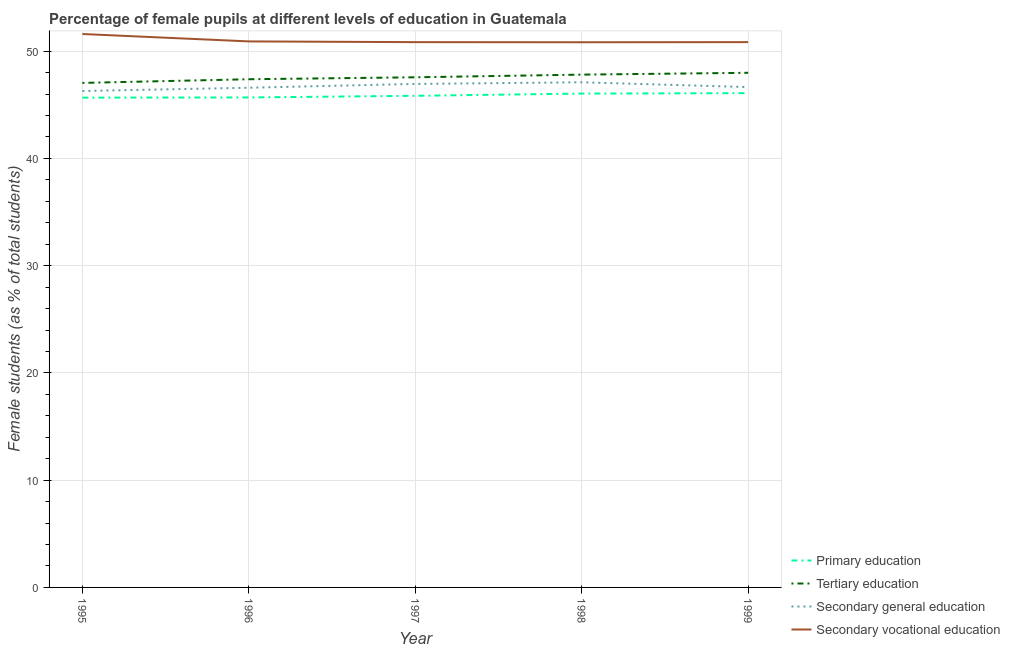How many different coloured lines are there?
Offer a terse response. 4. Is the number of lines equal to the number of legend labels?
Your response must be concise. Yes. What is the percentage of female students in primary education in 1999?
Your answer should be very brief. 46.09. Across all years, what is the maximum percentage of female students in secondary vocational education?
Give a very brief answer. 51.6. Across all years, what is the minimum percentage of female students in primary education?
Provide a succinct answer. 45.67. In which year was the percentage of female students in secondary education minimum?
Provide a succinct answer. 1995. What is the total percentage of female students in primary education in the graph?
Your answer should be very brief. 229.33. What is the difference between the percentage of female students in secondary vocational education in 1995 and that in 1997?
Provide a succinct answer. 0.76. What is the difference between the percentage of female students in secondary vocational education in 1997 and the percentage of female students in tertiary education in 1995?
Offer a very short reply. 3.8. What is the average percentage of female students in secondary vocational education per year?
Give a very brief answer. 51.01. In the year 1996, what is the difference between the percentage of female students in tertiary education and percentage of female students in primary education?
Make the answer very short. 1.7. In how many years, is the percentage of female students in secondary education greater than 22 %?
Your answer should be very brief. 5. What is the ratio of the percentage of female students in tertiary education in 1996 to that in 1997?
Provide a succinct answer. 1. What is the difference between the highest and the second highest percentage of female students in secondary vocational education?
Your answer should be very brief. 0.69. What is the difference between the highest and the lowest percentage of female students in secondary education?
Your answer should be very brief. 0.81. In how many years, is the percentage of female students in primary education greater than the average percentage of female students in primary education taken over all years?
Provide a succinct answer. 2. Is it the case that in every year, the sum of the percentage of female students in primary education and percentage of female students in tertiary education is greater than the percentage of female students in secondary education?
Ensure brevity in your answer.  Yes. Is the percentage of female students in tertiary education strictly less than the percentage of female students in secondary vocational education over the years?
Provide a succinct answer. Yes. How many lines are there?
Provide a short and direct response. 4. What is the difference between two consecutive major ticks on the Y-axis?
Your response must be concise. 10. Are the values on the major ticks of Y-axis written in scientific E-notation?
Give a very brief answer. No. Where does the legend appear in the graph?
Offer a very short reply. Bottom right. What is the title of the graph?
Offer a terse response. Percentage of female pupils at different levels of education in Guatemala. Does "Quality Certification" appear as one of the legend labels in the graph?
Offer a terse response. No. What is the label or title of the Y-axis?
Ensure brevity in your answer.  Female students (as % of total students). What is the Female students (as % of total students) of Primary education in 1995?
Make the answer very short. 45.67. What is the Female students (as % of total students) in Tertiary education in 1995?
Give a very brief answer. 47.04. What is the Female students (as % of total students) of Secondary general education in 1995?
Ensure brevity in your answer.  46.29. What is the Female students (as % of total students) in Secondary vocational education in 1995?
Your answer should be very brief. 51.6. What is the Female students (as % of total students) of Primary education in 1996?
Provide a succinct answer. 45.69. What is the Female students (as % of total students) of Tertiary education in 1996?
Offer a terse response. 47.38. What is the Female students (as % of total students) in Secondary general education in 1996?
Your answer should be very brief. 46.59. What is the Female students (as % of total students) of Secondary vocational education in 1996?
Your response must be concise. 50.91. What is the Female students (as % of total students) in Primary education in 1997?
Make the answer very short. 45.84. What is the Female students (as % of total students) of Tertiary education in 1997?
Make the answer very short. 47.57. What is the Female students (as % of total students) of Secondary general education in 1997?
Keep it short and to the point. 46.95. What is the Female students (as % of total students) of Secondary vocational education in 1997?
Your response must be concise. 50.84. What is the Female students (as % of total students) of Primary education in 1998?
Provide a short and direct response. 46.05. What is the Female students (as % of total students) of Tertiary education in 1998?
Ensure brevity in your answer.  47.81. What is the Female students (as % of total students) of Secondary general education in 1998?
Provide a succinct answer. 47.1. What is the Female students (as % of total students) of Secondary vocational education in 1998?
Offer a very short reply. 50.83. What is the Female students (as % of total students) of Primary education in 1999?
Keep it short and to the point. 46.09. What is the Female students (as % of total students) of Tertiary education in 1999?
Offer a terse response. 47.98. What is the Female students (as % of total students) of Secondary general education in 1999?
Offer a terse response. 46.65. What is the Female students (as % of total students) of Secondary vocational education in 1999?
Your answer should be compact. 50.84. Across all years, what is the maximum Female students (as % of total students) of Primary education?
Give a very brief answer. 46.09. Across all years, what is the maximum Female students (as % of total students) of Tertiary education?
Make the answer very short. 47.98. Across all years, what is the maximum Female students (as % of total students) in Secondary general education?
Offer a very short reply. 47.1. Across all years, what is the maximum Female students (as % of total students) of Secondary vocational education?
Offer a very short reply. 51.6. Across all years, what is the minimum Female students (as % of total students) of Primary education?
Provide a succinct answer. 45.67. Across all years, what is the minimum Female students (as % of total students) of Tertiary education?
Offer a very short reply. 47.04. Across all years, what is the minimum Female students (as % of total students) of Secondary general education?
Give a very brief answer. 46.29. Across all years, what is the minimum Female students (as % of total students) in Secondary vocational education?
Provide a short and direct response. 50.83. What is the total Female students (as % of total students) in Primary education in the graph?
Your answer should be compact. 229.33. What is the total Female students (as % of total students) in Tertiary education in the graph?
Ensure brevity in your answer.  237.79. What is the total Female students (as % of total students) of Secondary general education in the graph?
Give a very brief answer. 233.58. What is the total Female students (as % of total students) in Secondary vocational education in the graph?
Offer a very short reply. 255.03. What is the difference between the Female students (as % of total students) in Primary education in 1995 and that in 1996?
Your answer should be very brief. -0.02. What is the difference between the Female students (as % of total students) in Tertiary education in 1995 and that in 1996?
Give a very brief answer. -0.34. What is the difference between the Female students (as % of total students) of Secondary general education in 1995 and that in 1996?
Keep it short and to the point. -0.3. What is the difference between the Female students (as % of total students) in Secondary vocational education in 1995 and that in 1996?
Ensure brevity in your answer.  0.69. What is the difference between the Female students (as % of total students) in Primary education in 1995 and that in 1997?
Provide a short and direct response. -0.17. What is the difference between the Female students (as % of total students) of Tertiary education in 1995 and that in 1997?
Make the answer very short. -0.52. What is the difference between the Female students (as % of total students) in Secondary general education in 1995 and that in 1997?
Provide a short and direct response. -0.66. What is the difference between the Female students (as % of total students) of Secondary vocational education in 1995 and that in 1997?
Offer a terse response. 0.76. What is the difference between the Female students (as % of total students) of Primary education in 1995 and that in 1998?
Provide a succinct answer. -0.38. What is the difference between the Female students (as % of total students) in Tertiary education in 1995 and that in 1998?
Give a very brief answer. -0.77. What is the difference between the Female students (as % of total students) in Secondary general education in 1995 and that in 1998?
Keep it short and to the point. -0.81. What is the difference between the Female students (as % of total students) of Secondary vocational education in 1995 and that in 1998?
Make the answer very short. 0.77. What is the difference between the Female students (as % of total students) in Primary education in 1995 and that in 1999?
Offer a terse response. -0.42. What is the difference between the Female students (as % of total students) in Tertiary education in 1995 and that in 1999?
Ensure brevity in your answer.  -0.94. What is the difference between the Female students (as % of total students) in Secondary general education in 1995 and that in 1999?
Offer a terse response. -0.37. What is the difference between the Female students (as % of total students) in Secondary vocational education in 1995 and that in 1999?
Keep it short and to the point. 0.76. What is the difference between the Female students (as % of total students) in Primary education in 1996 and that in 1997?
Your response must be concise. -0.15. What is the difference between the Female students (as % of total students) in Tertiary education in 1996 and that in 1997?
Your response must be concise. -0.18. What is the difference between the Female students (as % of total students) of Secondary general education in 1996 and that in 1997?
Keep it short and to the point. -0.35. What is the difference between the Female students (as % of total students) of Secondary vocational education in 1996 and that in 1997?
Make the answer very short. 0.07. What is the difference between the Female students (as % of total students) in Primary education in 1996 and that in 1998?
Provide a short and direct response. -0.36. What is the difference between the Female students (as % of total students) in Tertiary education in 1996 and that in 1998?
Ensure brevity in your answer.  -0.43. What is the difference between the Female students (as % of total students) in Secondary general education in 1996 and that in 1998?
Your answer should be compact. -0.51. What is the difference between the Female students (as % of total students) of Secondary vocational education in 1996 and that in 1998?
Offer a terse response. 0.08. What is the difference between the Female students (as % of total students) in Primary education in 1996 and that in 1999?
Provide a short and direct response. -0.4. What is the difference between the Female students (as % of total students) in Tertiary education in 1996 and that in 1999?
Offer a very short reply. -0.6. What is the difference between the Female students (as % of total students) in Secondary general education in 1996 and that in 1999?
Provide a short and direct response. -0.06. What is the difference between the Female students (as % of total students) in Secondary vocational education in 1996 and that in 1999?
Provide a short and direct response. 0.07. What is the difference between the Female students (as % of total students) in Primary education in 1997 and that in 1998?
Provide a succinct answer. -0.21. What is the difference between the Female students (as % of total students) in Tertiary education in 1997 and that in 1998?
Give a very brief answer. -0.25. What is the difference between the Female students (as % of total students) of Secondary general education in 1997 and that in 1998?
Make the answer very short. -0.15. What is the difference between the Female students (as % of total students) of Secondary vocational education in 1997 and that in 1998?
Keep it short and to the point. 0.01. What is the difference between the Female students (as % of total students) of Primary education in 1997 and that in 1999?
Offer a very short reply. -0.25. What is the difference between the Female students (as % of total students) in Tertiary education in 1997 and that in 1999?
Provide a succinct answer. -0.42. What is the difference between the Female students (as % of total students) of Secondary general education in 1997 and that in 1999?
Offer a very short reply. 0.29. What is the difference between the Female students (as % of total students) of Secondary vocational education in 1997 and that in 1999?
Provide a succinct answer. -0. What is the difference between the Female students (as % of total students) in Primary education in 1998 and that in 1999?
Offer a terse response. -0.04. What is the difference between the Female students (as % of total students) in Tertiary education in 1998 and that in 1999?
Keep it short and to the point. -0.17. What is the difference between the Female students (as % of total students) of Secondary general education in 1998 and that in 1999?
Give a very brief answer. 0.45. What is the difference between the Female students (as % of total students) of Secondary vocational education in 1998 and that in 1999?
Keep it short and to the point. -0.01. What is the difference between the Female students (as % of total students) in Primary education in 1995 and the Female students (as % of total students) in Tertiary education in 1996?
Your response must be concise. -1.72. What is the difference between the Female students (as % of total students) of Primary education in 1995 and the Female students (as % of total students) of Secondary general education in 1996?
Your answer should be very brief. -0.93. What is the difference between the Female students (as % of total students) of Primary education in 1995 and the Female students (as % of total students) of Secondary vocational education in 1996?
Ensure brevity in your answer.  -5.24. What is the difference between the Female students (as % of total students) of Tertiary education in 1995 and the Female students (as % of total students) of Secondary general education in 1996?
Your answer should be very brief. 0.45. What is the difference between the Female students (as % of total students) of Tertiary education in 1995 and the Female students (as % of total students) of Secondary vocational education in 1996?
Offer a very short reply. -3.87. What is the difference between the Female students (as % of total students) of Secondary general education in 1995 and the Female students (as % of total students) of Secondary vocational education in 1996?
Provide a succinct answer. -4.62. What is the difference between the Female students (as % of total students) of Primary education in 1995 and the Female students (as % of total students) of Tertiary education in 1997?
Your answer should be very brief. -1.9. What is the difference between the Female students (as % of total students) in Primary education in 1995 and the Female students (as % of total students) in Secondary general education in 1997?
Provide a short and direct response. -1.28. What is the difference between the Female students (as % of total students) in Primary education in 1995 and the Female students (as % of total students) in Secondary vocational education in 1997?
Give a very brief answer. -5.18. What is the difference between the Female students (as % of total students) of Tertiary education in 1995 and the Female students (as % of total students) of Secondary general education in 1997?
Your answer should be compact. 0.09. What is the difference between the Female students (as % of total students) of Tertiary education in 1995 and the Female students (as % of total students) of Secondary vocational education in 1997?
Keep it short and to the point. -3.8. What is the difference between the Female students (as % of total students) of Secondary general education in 1995 and the Female students (as % of total students) of Secondary vocational education in 1997?
Make the answer very short. -4.56. What is the difference between the Female students (as % of total students) in Primary education in 1995 and the Female students (as % of total students) in Tertiary education in 1998?
Offer a very short reply. -2.15. What is the difference between the Female students (as % of total students) in Primary education in 1995 and the Female students (as % of total students) in Secondary general education in 1998?
Offer a terse response. -1.43. What is the difference between the Female students (as % of total students) in Primary education in 1995 and the Female students (as % of total students) in Secondary vocational education in 1998?
Provide a short and direct response. -5.17. What is the difference between the Female students (as % of total students) in Tertiary education in 1995 and the Female students (as % of total students) in Secondary general education in 1998?
Offer a very short reply. -0.06. What is the difference between the Female students (as % of total students) in Tertiary education in 1995 and the Female students (as % of total students) in Secondary vocational education in 1998?
Offer a very short reply. -3.79. What is the difference between the Female students (as % of total students) in Secondary general education in 1995 and the Female students (as % of total students) in Secondary vocational education in 1998?
Give a very brief answer. -4.55. What is the difference between the Female students (as % of total students) of Primary education in 1995 and the Female students (as % of total students) of Tertiary education in 1999?
Provide a short and direct response. -2.32. What is the difference between the Female students (as % of total students) in Primary education in 1995 and the Female students (as % of total students) in Secondary general education in 1999?
Your answer should be very brief. -0.99. What is the difference between the Female students (as % of total students) of Primary education in 1995 and the Female students (as % of total students) of Secondary vocational education in 1999?
Your response must be concise. -5.18. What is the difference between the Female students (as % of total students) in Tertiary education in 1995 and the Female students (as % of total students) in Secondary general education in 1999?
Provide a short and direct response. 0.39. What is the difference between the Female students (as % of total students) in Tertiary education in 1995 and the Female students (as % of total students) in Secondary vocational education in 1999?
Make the answer very short. -3.8. What is the difference between the Female students (as % of total students) in Secondary general education in 1995 and the Female students (as % of total students) in Secondary vocational education in 1999?
Give a very brief answer. -4.56. What is the difference between the Female students (as % of total students) in Primary education in 1996 and the Female students (as % of total students) in Tertiary education in 1997?
Offer a terse response. -1.88. What is the difference between the Female students (as % of total students) of Primary education in 1996 and the Female students (as % of total students) of Secondary general education in 1997?
Give a very brief answer. -1.26. What is the difference between the Female students (as % of total students) in Primary education in 1996 and the Female students (as % of total students) in Secondary vocational education in 1997?
Keep it short and to the point. -5.16. What is the difference between the Female students (as % of total students) in Tertiary education in 1996 and the Female students (as % of total students) in Secondary general education in 1997?
Your response must be concise. 0.44. What is the difference between the Female students (as % of total students) of Tertiary education in 1996 and the Female students (as % of total students) of Secondary vocational education in 1997?
Make the answer very short. -3.46. What is the difference between the Female students (as % of total students) of Secondary general education in 1996 and the Female students (as % of total students) of Secondary vocational education in 1997?
Offer a terse response. -4.25. What is the difference between the Female students (as % of total students) in Primary education in 1996 and the Female students (as % of total students) in Tertiary education in 1998?
Keep it short and to the point. -2.13. What is the difference between the Female students (as % of total students) of Primary education in 1996 and the Female students (as % of total students) of Secondary general education in 1998?
Your answer should be very brief. -1.41. What is the difference between the Female students (as % of total students) of Primary education in 1996 and the Female students (as % of total students) of Secondary vocational education in 1998?
Your answer should be very brief. -5.15. What is the difference between the Female students (as % of total students) in Tertiary education in 1996 and the Female students (as % of total students) in Secondary general education in 1998?
Your response must be concise. 0.29. What is the difference between the Female students (as % of total students) in Tertiary education in 1996 and the Female students (as % of total students) in Secondary vocational education in 1998?
Give a very brief answer. -3.45. What is the difference between the Female students (as % of total students) in Secondary general education in 1996 and the Female students (as % of total students) in Secondary vocational education in 1998?
Provide a succinct answer. -4.24. What is the difference between the Female students (as % of total students) of Primary education in 1996 and the Female students (as % of total students) of Tertiary education in 1999?
Provide a short and direct response. -2.3. What is the difference between the Female students (as % of total students) in Primary education in 1996 and the Female students (as % of total students) in Secondary general education in 1999?
Provide a succinct answer. -0.97. What is the difference between the Female students (as % of total students) in Primary education in 1996 and the Female students (as % of total students) in Secondary vocational education in 1999?
Your answer should be compact. -5.16. What is the difference between the Female students (as % of total students) of Tertiary education in 1996 and the Female students (as % of total students) of Secondary general education in 1999?
Offer a terse response. 0.73. What is the difference between the Female students (as % of total students) in Tertiary education in 1996 and the Female students (as % of total students) in Secondary vocational education in 1999?
Ensure brevity in your answer.  -3.46. What is the difference between the Female students (as % of total students) in Secondary general education in 1996 and the Female students (as % of total students) in Secondary vocational education in 1999?
Your answer should be compact. -4.25. What is the difference between the Female students (as % of total students) in Primary education in 1997 and the Female students (as % of total students) in Tertiary education in 1998?
Provide a succinct answer. -1.97. What is the difference between the Female students (as % of total students) of Primary education in 1997 and the Female students (as % of total students) of Secondary general education in 1998?
Keep it short and to the point. -1.26. What is the difference between the Female students (as % of total students) of Primary education in 1997 and the Female students (as % of total students) of Secondary vocational education in 1998?
Give a very brief answer. -4.99. What is the difference between the Female students (as % of total students) of Tertiary education in 1997 and the Female students (as % of total students) of Secondary general education in 1998?
Your answer should be compact. 0.47. What is the difference between the Female students (as % of total students) in Tertiary education in 1997 and the Female students (as % of total students) in Secondary vocational education in 1998?
Ensure brevity in your answer.  -3.27. What is the difference between the Female students (as % of total students) of Secondary general education in 1997 and the Female students (as % of total students) of Secondary vocational education in 1998?
Your response must be concise. -3.89. What is the difference between the Female students (as % of total students) of Primary education in 1997 and the Female students (as % of total students) of Tertiary education in 1999?
Offer a terse response. -2.14. What is the difference between the Female students (as % of total students) of Primary education in 1997 and the Female students (as % of total students) of Secondary general education in 1999?
Your response must be concise. -0.81. What is the difference between the Female students (as % of total students) in Primary education in 1997 and the Female students (as % of total students) in Secondary vocational education in 1999?
Offer a very short reply. -5. What is the difference between the Female students (as % of total students) in Tertiary education in 1997 and the Female students (as % of total students) in Secondary general education in 1999?
Your response must be concise. 0.91. What is the difference between the Female students (as % of total students) of Tertiary education in 1997 and the Female students (as % of total students) of Secondary vocational education in 1999?
Provide a succinct answer. -3.28. What is the difference between the Female students (as % of total students) of Secondary general education in 1997 and the Female students (as % of total students) of Secondary vocational education in 1999?
Ensure brevity in your answer.  -3.9. What is the difference between the Female students (as % of total students) in Primary education in 1998 and the Female students (as % of total students) in Tertiary education in 1999?
Keep it short and to the point. -1.94. What is the difference between the Female students (as % of total students) in Primary education in 1998 and the Female students (as % of total students) in Secondary general education in 1999?
Your answer should be compact. -0.61. What is the difference between the Female students (as % of total students) of Primary education in 1998 and the Female students (as % of total students) of Secondary vocational education in 1999?
Your answer should be very brief. -4.8. What is the difference between the Female students (as % of total students) in Tertiary education in 1998 and the Female students (as % of total students) in Secondary general education in 1999?
Provide a succinct answer. 1.16. What is the difference between the Female students (as % of total students) in Tertiary education in 1998 and the Female students (as % of total students) in Secondary vocational education in 1999?
Offer a terse response. -3.03. What is the difference between the Female students (as % of total students) of Secondary general education in 1998 and the Female students (as % of total students) of Secondary vocational education in 1999?
Provide a succinct answer. -3.75. What is the average Female students (as % of total students) of Primary education per year?
Offer a terse response. 45.87. What is the average Female students (as % of total students) in Tertiary education per year?
Offer a very short reply. 47.56. What is the average Female students (as % of total students) of Secondary general education per year?
Ensure brevity in your answer.  46.72. What is the average Female students (as % of total students) of Secondary vocational education per year?
Provide a succinct answer. 51.01. In the year 1995, what is the difference between the Female students (as % of total students) in Primary education and Female students (as % of total students) in Tertiary education?
Make the answer very short. -1.37. In the year 1995, what is the difference between the Female students (as % of total students) in Primary education and Female students (as % of total students) in Secondary general education?
Keep it short and to the point. -0.62. In the year 1995, what is the difference between the Female students (as % of total students) in Primary education and Female students (as % of total students) in Secondary vocational education?
Give a very brief answer. -5.93. In the year 1995, what is the difference between the Female students (as % of total students) of Tertiary education and Female students (as % of total students) of Secondary general education?
Give a very brief answer. 0.75. In the year 1995, what is the difference between the Female students (as % of total students) in Tertiary education and Female students (as % of total students) in Secondary vocational education?
Give a very brief answer. -4.56. In the year 1995, what is the difference between the Female students (as % of total students) of Secondary general education and Female students (as % of total students) of Secondary vocational education?
Your answer should be very brief. -5.31. In the year 1996, what is the difference between the Female students (as % of total students) in Primary education and Female students (as % of total students) in Tertiary education?
Make the answer very short. -1.7. In the year 1996, what is the difference between the Female students (as % of total students) of Primary education and Female students (as % of total students) of Secondary general education?
Offer a very short reply. -0.9. In the year 1996, what is the difference between the Female students (as % of total students) in Primary education and Female students (as % of total students) in Secondary vocational education?
Give a very brief answer. -5.22. In the year 1996, what is the difference between the Female students (as % of total students) in Tertiary education and Female students (as % of total students) in Secondary general education?
Your answer should be very brief. 0.79. In the year 1996, what is the difference between the Female students (as % of total students) in Tertiary education and Female students (as % of total students) in Secondary vocational education?
Keep it short and to the point. -3.53. In the year 1996, what is the difference between the Female students (as % of total students) of Secondary general education and Female students (as % of total students) of Secondary vocational education?
Give a very brief answer. -4.32. In the year 1997, what is the difference between the Female students (as % of total students) in Primary education and Female students (as % of total students) in Tertiary education?
Keep it short and to the point. -1.73. In the year 1997, what is the difference between the Female students (as % of total students) in Primary education and Female students (as % of total students) in Secondary general education?
Provide a succinct answer. -1.11. In the year 1997, what is the difference between the Female students (as % of total students) in Primary education and Female students (as % of total students) in Secondary vocational education?
Provide a short and direct response. -5. In the year 1997, what is the difference between the Female students (as % of total students) in Tertiary education and Female students (as % of total students) in Secondary general education?
Keep it short and to the point. 0.62. In the year 1997, what is the difference between the Female students (as % of total students) of Tertiary education and Female students (as % of total students) of Secondary vocational education?
Offer a terse response. -3.28. In the year 1997, what is the difference between the Female students (as % of total students) in Secondary general education and Female students (as % of total students) in Secondary vocational education?
Your response must be concise. -3.9. In the year 1998, what is the difference between the Female students (as % of total students) in Primary education and Female students (as % of total students) in Tertiary education?
Make the answer very short. -1.77. In the year 1998, what is the difference between the Female students (as % of total students) of Primary education and Female students (as % of total students) of Secondary general education?
Your answer should be compact. -1.05. In the year 1998, what is the difference between the Female students (as % of total students) of Primary education and Female students (as % of total students) of Secondary vocational education?
Keep it short and to the point. -4.79. In the year 1998, what is the difference between the Female students (as % of total students) of Tertiary education and Female students (as % of total students) of Secondary general education?
Make the answer very short. 0.71. In the year 1998, what is the difference between the Female students (as % of total students) of Tertiary education and Female students (as % of total students) of Secondary vocational education?
Your answer should be very brief. -3.02. In the year 1998, what is the difference between the Female students (as % of total students) of Secondary general education and Female students (as % of total students) of Secondary vocational education?
Give a very brief answer. -3.73. In the year 1999, what is the difference between the Female students (as % of total students) of Primary education and Female students (as % of total students) of Tertiary education?
Offer a terse response. -1.9. In the year 1999, what is the difference between the Female students (as % of total students) of Primary education and Female students (as % of total students) of Secondary general education?
Provide a succinct answer. -0.57. In the year 1999, what is the difference between the Female students (as % of total students) of Primary education and Female students (as % of total students) of Secondary vocational education?
Provide a succinct answer. -4.76. In the year 1999, what is the difference between the Female students (as % of total students) in Tertiary education and Female students (as % of total students) in Secondary general education?
Ensure brevity in your answer.  1.33. In the year 1999, what is the difference between the Female students (as % of total students) of Tertiary education and Female students (as % of total students) of Secondary vocational education?
Keep it short and to the point. -2.86. In the year 1999, what is the difference between the Female students (as % of total students) in Secondary general education and Female students (as % of total students) in Secondary vocational education?
Keep it short and to the point. -4.19. What is the ratio of the Female students (as % of total students) in Primary education in 1995 to that in 1996?
Your response must be concise. 1. What is the ratio of the Female students (as % of total students) of Secondary general education in 1995 to that in 1996?
Offer a very short reply. 0.99. What is the ratio of the Female students (as % of total students) in Secondary vocational education in 1995 to that in 1996?
Offer a very short reply. 1.01. What is the ratio of the Female students (as % of total students) in Primary education in 1995 to that in 1997?
Your answer should be compact. 1. What is the ratio of the Female students (as % of total students) in Secondary general education in 1995 to that in 1997?
Provide a short and direct response. 0.99. What is the ratio of the Female students (as % of total students) in Secondary vocational education in 1995 to that in 1997?
Your response must be concise. 1.01. What is the ratio of the Female students (as % of total students) in Tertiary education in 1995 to that in 1998?
Offer a terse response. 0.98. What is the ratio of the Female students (as % of total students) of Secondary general education in 1995 to that in 1998?
Offer a very short reply. 0.98. What is the ratio of the Female students (as % of total students) in Secondary vocational education in 1995 to that in 1998?
Ensure brevity in your answer.  1.02. What is the ratio of the Female students (as % of total students) in Primary education in 1995 to that in 1999?
Provide a succinct answer. 0.99. What is the ratio of the Female students (as % of total students) in Tertiary education in 1995 to that in 1999?
Provide a succinct answer. 0.98. What is the ratio of the Female students (as % of total students) in Secondary general education in 1995 to that in 1999?
Your answer should be compact. 0.99. What is the ratio of the Female students (as % of total students) in Secondary vocational education in 1995 to that in 1999?
Keep it short and to the point. 1.01. What is the ratio of the Female students (as % of total students) of Secondary general education in 1996 to that in 1997?
Your answer should be very brief. 0.99. What is the ratio of the Female students (as % of total students) in Secondary vocational education in 1996 to that in 1997?
Give a very brief answer. 1. What is the ratio of the Female students (as % of total students) in Tertiary education in 1996 to that in 1998?
Your answer should be compact. 0.99. What is the ratio of the Female students (as % of total students) of Secondary vocational education in 1996 to that in 1998?
Give a very brief answer. 1. What is the ratio of the Female students (as % of total students) in Primary education in 1996 to that in 1999?
Your answer should be very brief. 0.99. What is the ratio of the Female students (as % of total students) of Tertiary education in 1996 to that in 1999?
Offer a terse response. 0.99. What is the ratio of the Female students (as % of total students) in Secondary general education in 1996 to that in 1999?
Your response must be concise. 1. What is the ratio of the Female students (as % of total students) in Tertiary education in 1997 to that in 1998?
Make the answer very short. 0.99. What is the ratio of the Female students (as % of total students) of Secondary general education in 1997 to that in 1998?
Your response must be concise. 1. What is the ratio of the Female students (as % of total students) in Primary education in 1997 to that in 1999?
Provide a succinct answer. 0.99. What is the ratio of the Female students (as % of total students) of Secondary general education in 1997 to that in 1999?
Your answer should be very brief. 1.01. What is the ratio of the Female students (as % of total students) of Secondary vocational education in 1997 to that in 1999?
Your answer should be compact. 1. What is the ratio of the Female students (as % of total students) of Primary education in 1998 to that in 1999?
Your answer should be compact. 1. What is the ratio of the Female students (as % of total students) of Secondary general education in 1998 to that in 1999?
Keep it short and to the point. 1.01. What is the ratio of the Female students (as % of total students) in Secondary vocational education in 1998 to that in 1999?
Offer a terse response. 1. What is the difference between the highest and the second highest Female students (as % of total students) of Primary education?
Provide a succinct answer. 0.04. What is the difference between the highest and the second highest Female students (as % of total students) in Tertiary education?
Your answer should be compact. 0.17. What is the difference between the highest and the second highest Female students (as % of total students) of Secondary general education?
Your response must be concise. 0.15. What is the difference between the highest and the second highest Female students (as % of total students) in Secondary vocational education?
Offer a very short reply. 0.69. What is the difference between the highest and the lowest Female students (as % of total students) in Primary education?
Make the answer very short. 0.42. What is the difference between the highest and the lowest Female students (as % of total students) of Tertiary education?
Your response must be concise. 0.94. What is the difference between the highest and the lowest Female students (as % of total students) in Secondary general education?
Provide a succinct answer. 0.81. What is the difference between the highest and the lowest Female students (as % of total students) in Secondary vocational education?
Give a very brief answer. 0.77. 